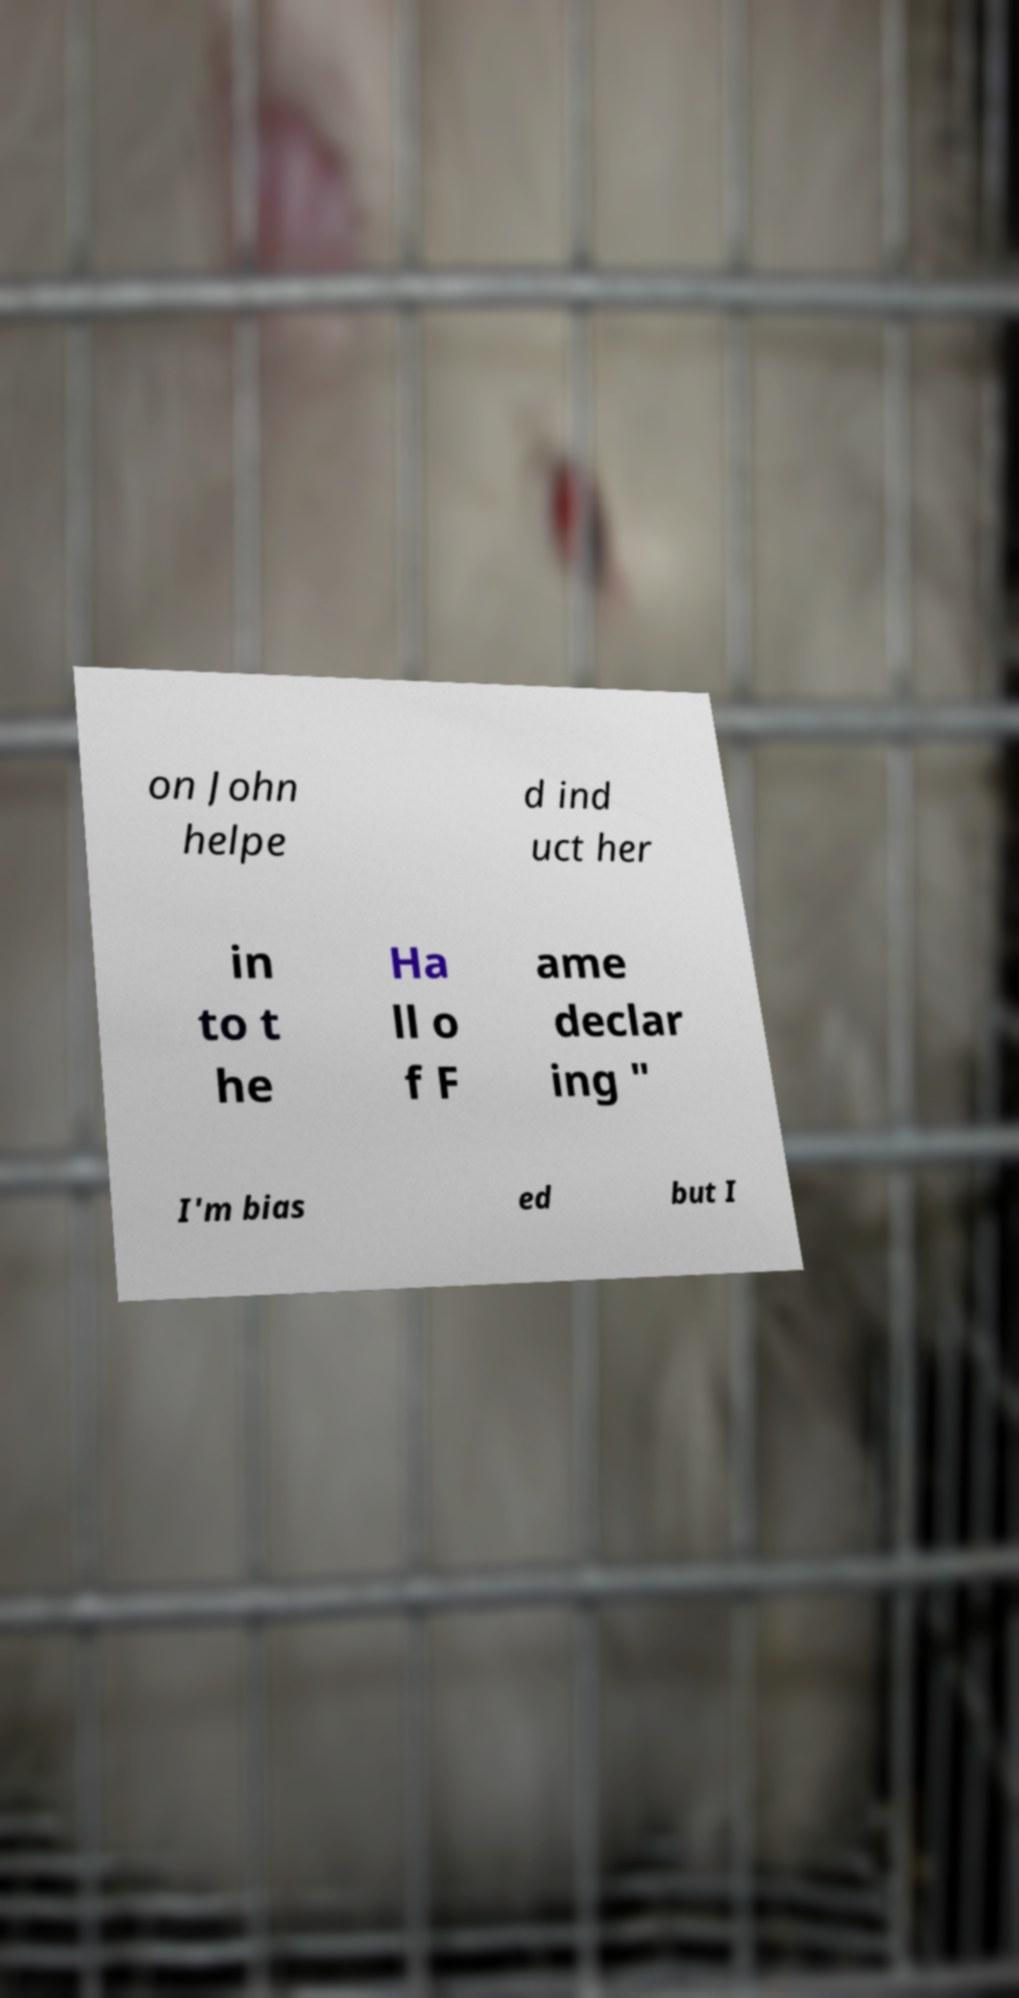What messages or text are displayed in this image? I need them in a readable, typed format. on John helpe d ind uct her in to t he Ha ll o f F ame declar ing " I'm bias ed but I 